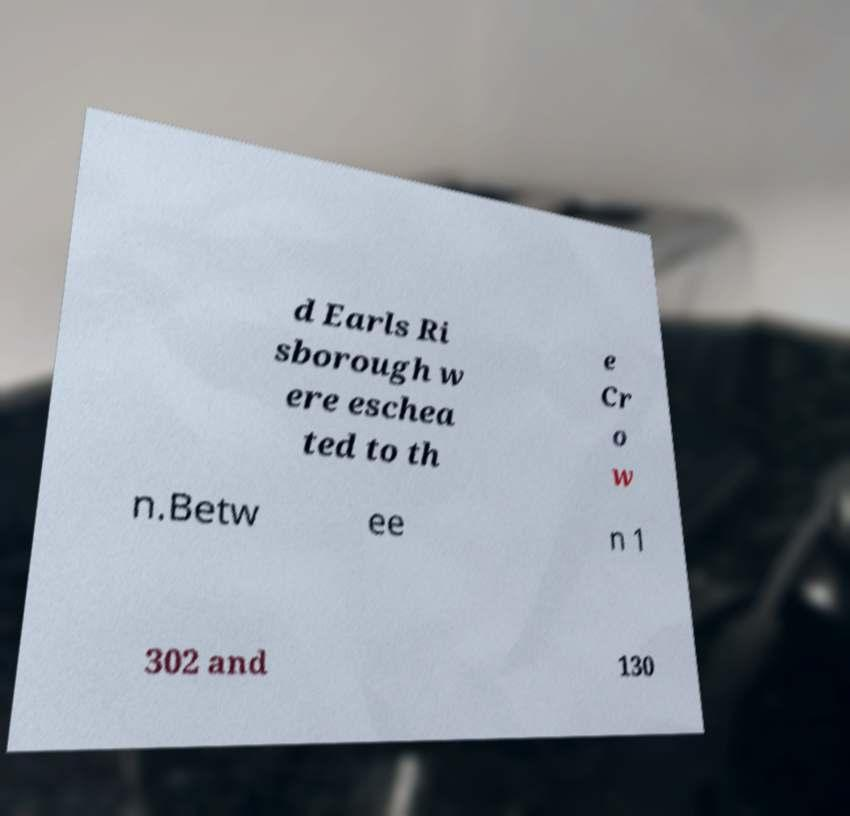Please read and relay the text visible in this image. What does it say? d Earls Ri sborough w ere eschea ted to th e Cr o w n.Betw ee n 1 302 and 130 